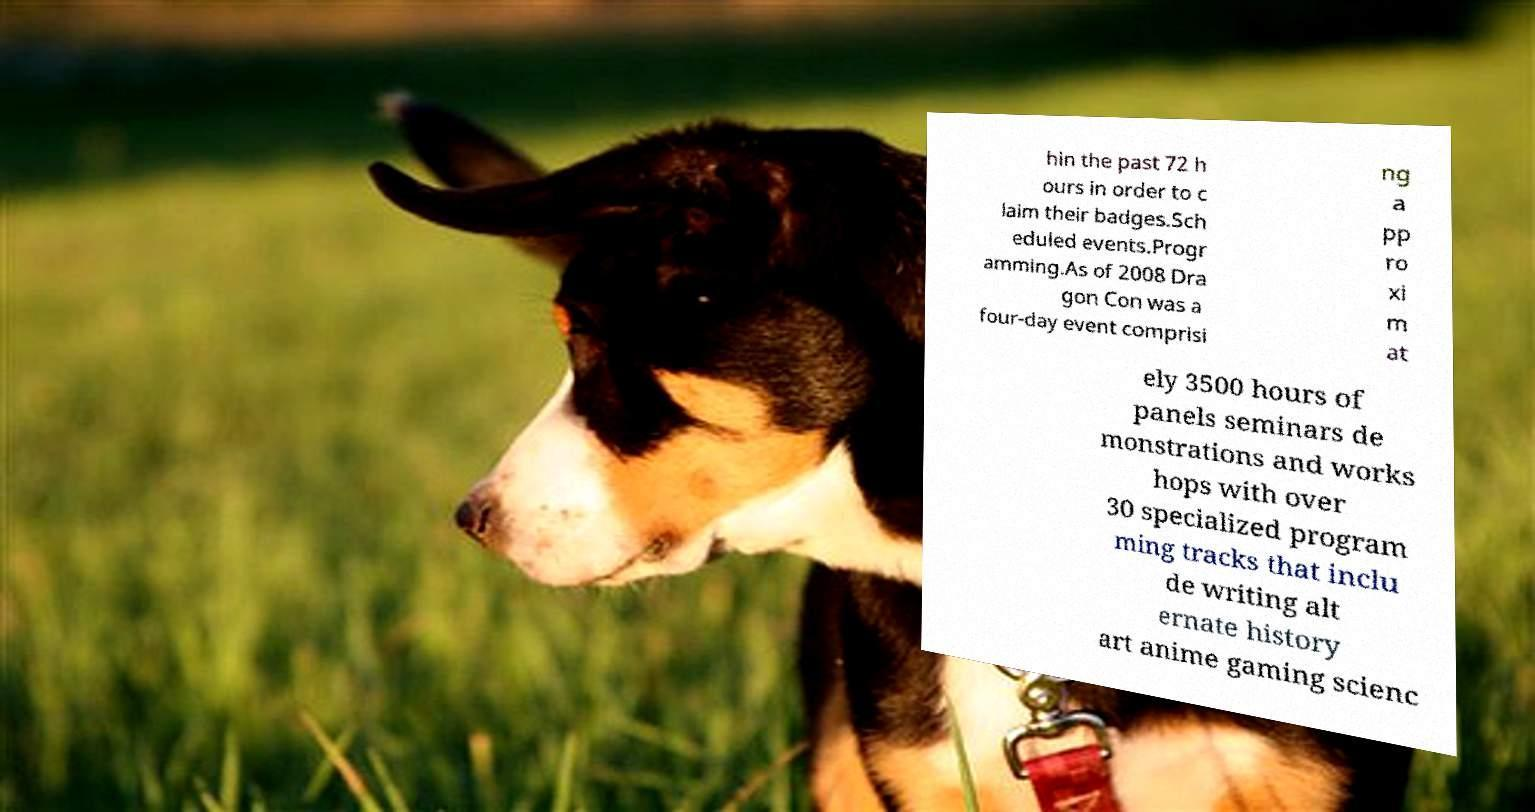I need the written content from this picture converted into text. Can you do that? hin the past 72 h ours in order to c laim their badges.Sch eduled events.Progr amming.As of 2008 Dra gon Con was a four-day event comprisi ng a pp ro xi m at ely 3500 hours of panels seminars de monstrations and works hops with over 30 specialized program ming tracks that inclu de writing alt ernate history art anime gaming scienc 